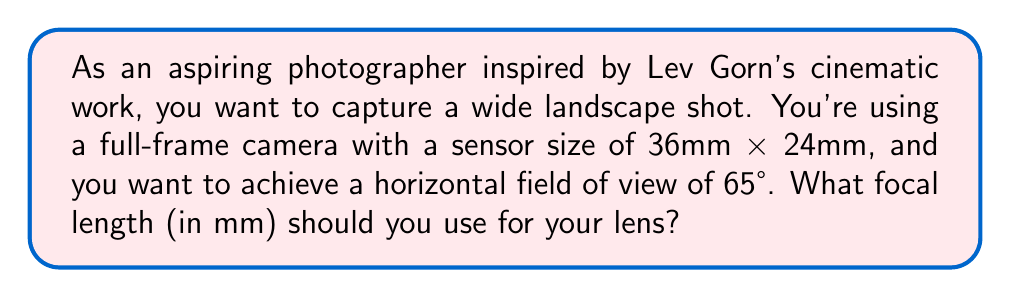Can you solve this math problem? To solve this problem, we need to use the relationship between focal length and field of view. The formula for calculating the horizontal field of view (FOV) is:

$$ FOV = 2 \arctan\left(\frac{w}{2f}\right) $$

Where:
$FOV$ is the field of view in radians
$w$ is the width of the sensor
$f$ is the focal length

We need to rearrange this formula to solve for $f$:

$$ \frac{FOV}{2} = \arctan\left(\frac{w}{2f}\right) $$
$$ \tan\left(\frac{FOV}{2}\right) = \frac{w}{2f} $$
$$ f = \frac{w}{2\tan\left(\frac{FOV}{2}\right)} $$

Now, let's plug in our known values:
$w = 36$ mm (width of a full-frame sensor)
$FOV = 65°$ (we need to convert this to radians)

Converting 65° to radians:
$$ 65° \times \frac{\pi}{180°} = 1.1345 \text{ radians} $$

Now we can calculate the focal length:

$$ f = \frac{36}{2\tan\left(\frac{1.1345}{2}\right)} $$
$$ f = \frac{36}{2\tan(0.56725)} $$
$$ f = \frac{36}{2 \times 0.6228} $$
$$ f = \frac{36}{1.2456} $$
$$ f \approx 28.90 \text{ mm} $$

Rounding to the nearest standard focal length, we get 28mm.
Answer: The required focal length is approximately 28mm. 